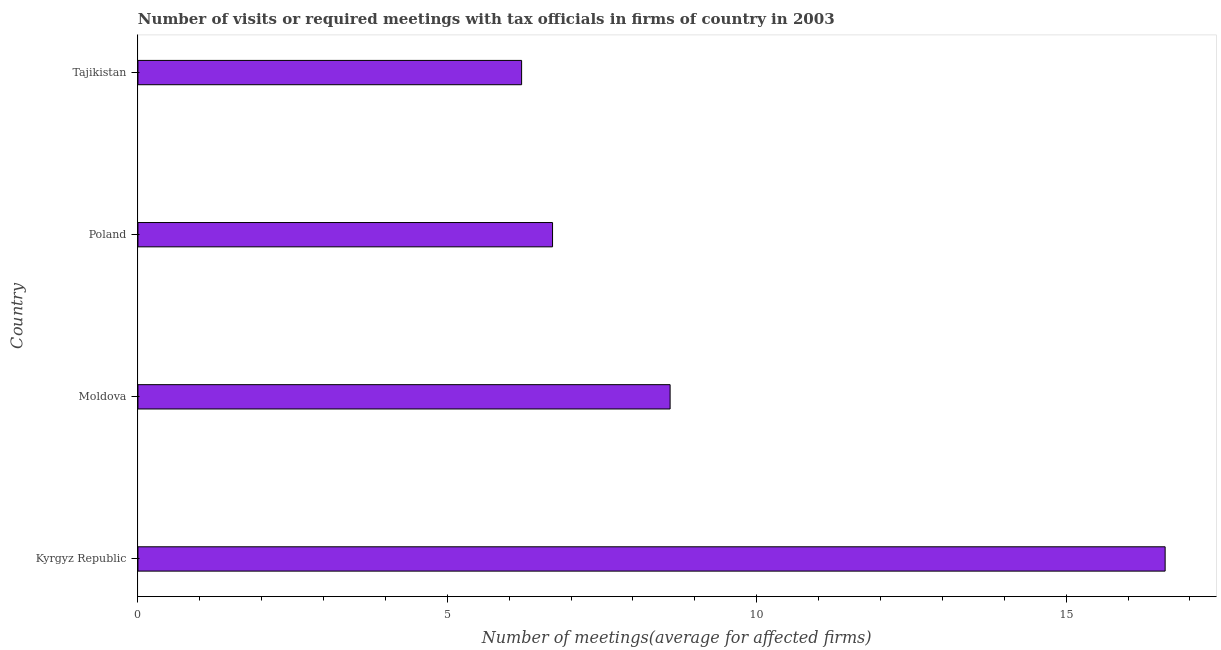Does the graph contain any zero values?
Give a very brief answer. No. Does the graph contain grids?
Give a very brief answer. No. What is the title of the graph?
Give a very brief answer. Number of visits or required meetings with tax officials in firms of country in 2003. What is the label or title of the X-axis?
Give a very brief answer. Number of meetings(average for affected firms). What is the number of required meetings with tax officials in Kyrgyz Republic?
Offer a terse response. 16.6. Across all countries, what is the maximum number of required meetings with tax officials?
Give a very brief answer. 16.6. Across all countries, what is the minimum number of required meetings with tax officials?
Provide a short and direct response. 6.2. In which country was the number of required meetings with tax officials maximum?
Provide a succinct answer. Kyrgyz Republic. In which country was the number of required meetings with tax officials minimum?
Your answer should be compact. Tajikistan. What is the sum of the number of required meetings with tax officials?
Your answer should be compact. 38.1. What is the difference between the number of required meetings with tax officials in Kyrgyz Republic and Poland?
Provide a succinct answer. 9.9. What is the average number of required meetings with tax officials per country?
Ensure brevity in your answer.  9.53. What is the median number of required meetings with tax officials?
Provide a short and direct response. 7.65. What is the ratio of the number of required meetings with tax officials in Kyrgyz Republic to that in Moldova?
Offer a terse response. 1.93. What is the difference between the highest and the second highest number of required meetings with tax officials?
Provide a short and direct response. 8. What is the difference between two consecutive major ticks on the X-axis?
Your response must be concise. 5. What is the Number of meetings(average for affected firms) in Moldova?
Provide a succinct answer. 8.6. What is the Number of meetings(average for affected firms) of Poland?
Your response must be concise. 6.7. What is the Number of meetings(average for affected firms) of Tajikistan?
Your answer should be compact. 6.2. What is the difference between the Number of meetings(average for affected firms) in Kyrgyz Republic and Moldova?
Your answer should be compact. 8. What is the difference between the Number of meetings(average for affected firms) in Kyrgyz Republic and Tajikistan?
Your answer should be very brief. 10.4. What is the difference between the Number of meetings(average for affected firms) in Moldova and Poland?
Provide a succinct answer. 1.9. What is the ratio of the Number of meetings(average for affected firms) in Kyrgyz Republic to that in Moldova?
Provide a short and direct response. 1.93. What is the ratio of the Number of meetings(average for affected firms) in Kyrgyz Republic to that in Poland?
Make the answer very short. 2.48. What is the ratio of the Number of meetings(average for affected firms) in Kyrgyz Republic to that in Tajikistan?
Make the answer very short. 2.68. What is the ratio of the Number of meetings(average for affected firms) in Moldova to that in Poland?
Your response must be concise. 1.28. What is the ratio of the Number of meetings(average for affected firms) in Moldova to that in Tajikistan?
Give a very brief answer. 1.39. What is the ratio of the Number of meetings(average for affected firms) in Poland to that in Tajikistan?
Provide a short and direct response. 1.08. 